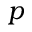Convert formula to latex. <formula><loc_0><loc_0><loc_500><loc_500>p</formula> 